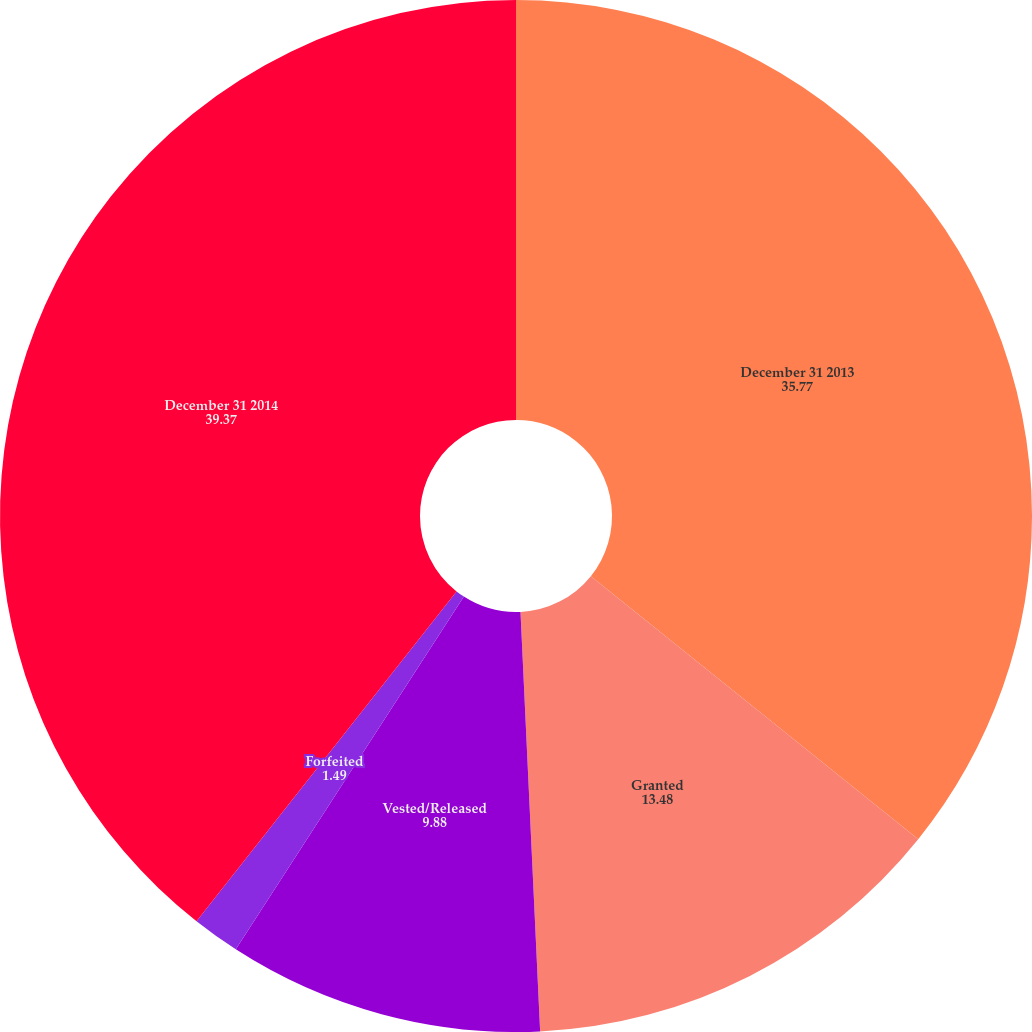Convert chart. <chart><loc_0><loc_0><loc_500><loc_500><pie_chart><fcel>December 31 2013<fcel>Granted<fcel>Vested/Released<fcel>Forfeited<fcel>December 31 2014<nl><fcel>35.77%<fcel>13.48%<fcel>9.88%<fcel>1.49%<fcel>39.37%<nl></chart> 